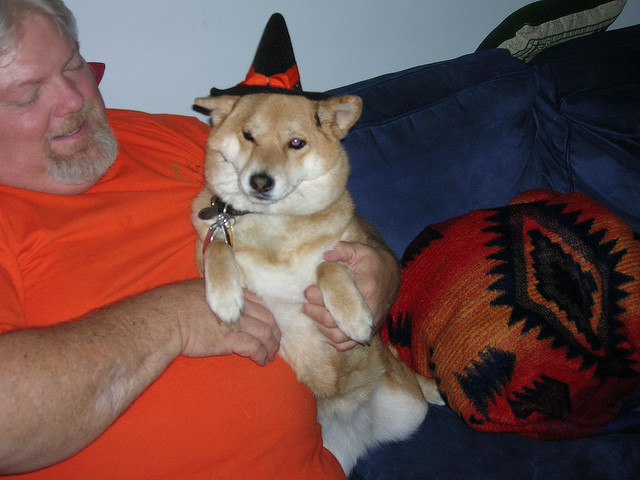<image>Why would this relationship normally be unusual? It is unknown why this relationship would normally be unusual. It could be because they are different species. What does the collar say? It is not possible to tell what the collar says. It might say nothing or have a name on it. Why would this relationship normally be unusual? I don't know why this relationship would normally be unusual. It can be because it's with dog, dogs don't wear hats or because they are different species. What does the collar say? I don't know what the collar says. It seems that there is nothing written on it. 